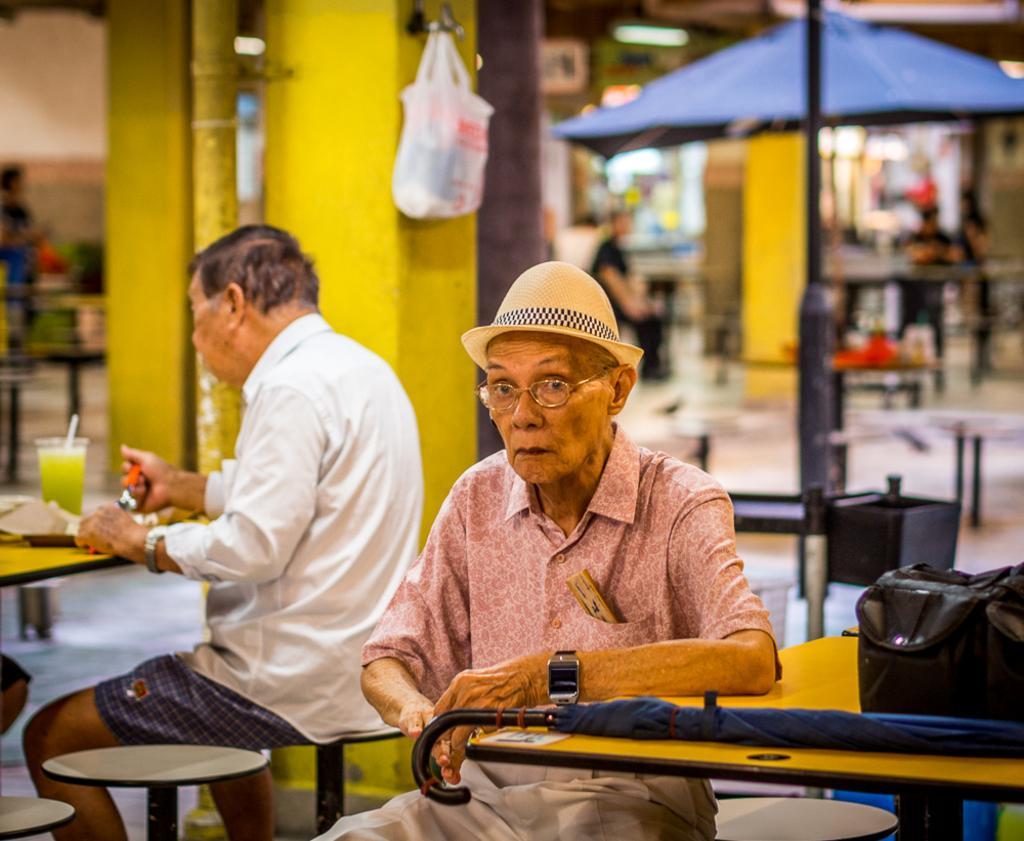Could you give a brief overview of what you see in this image? In this image I see 2 men who are sitting and there are tables in front of them, I can also see there are few things on it. In the background I see few people, wall and they're blurred. 